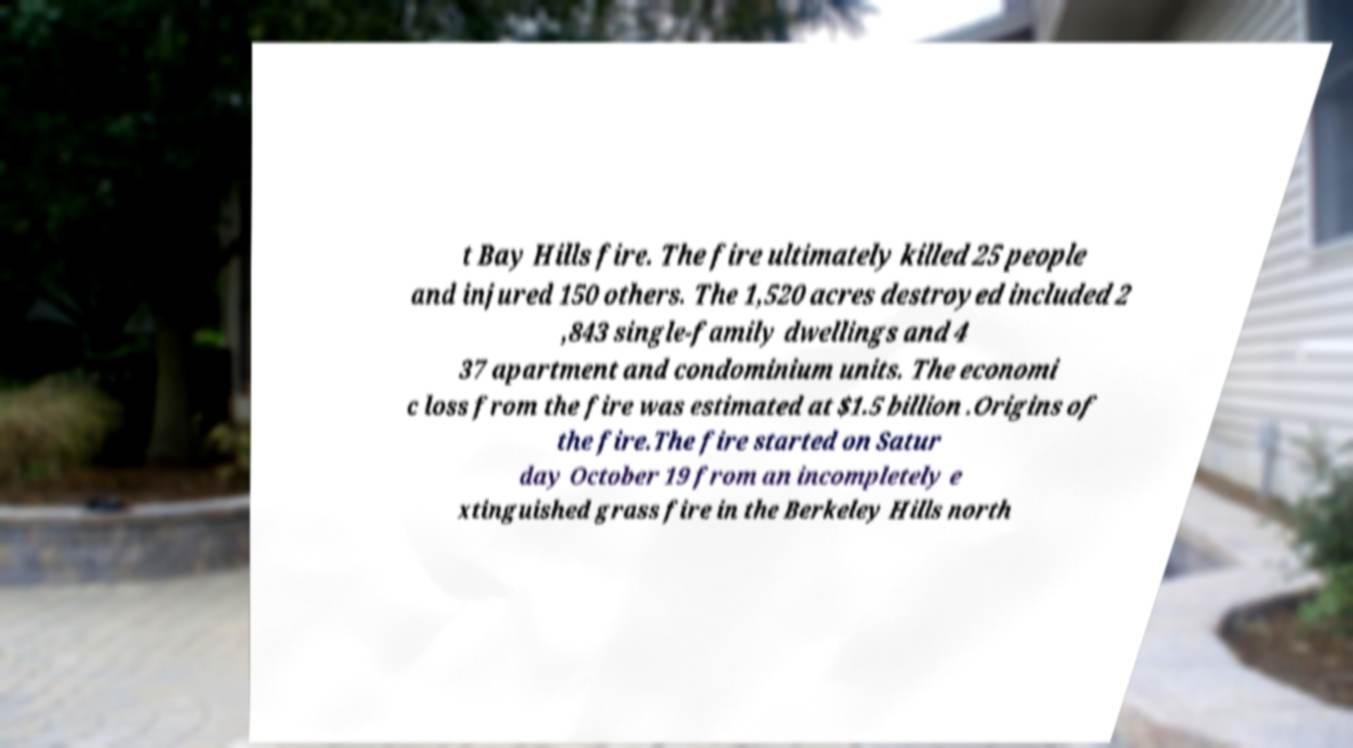For documentation purposes, I need the text within this image transcribed. Could you provide that? t Bay Hills fire. The fire ultimately killed 25 people and injured 150 others. The 1,520 acres destroyed included 2 ,843 single-family dwellings and 4 37 apartment and condominium units. The economi c loss from the fire was estimated at $1.5 billion .Origins of the fire.The fire started on Satur day October 19 from an incompletely e xtinguished grass fire in the Berkeley Hills north 